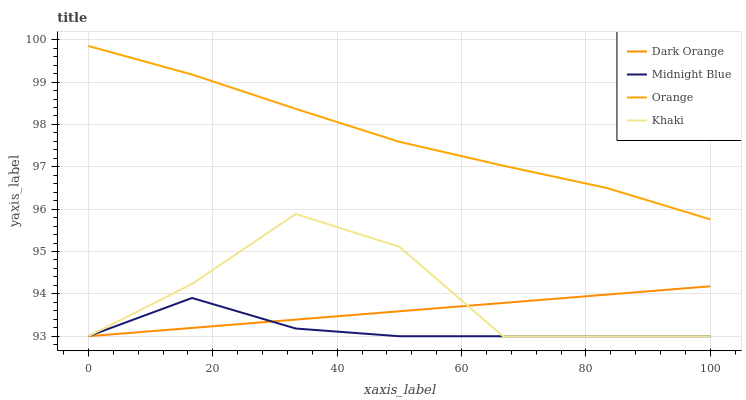Does Midnight Blue have the minimum area under the curve?
Answer yes or no. Yes. Does Orange have the maximum area under the curve?
Answer yes or no. Yes. Does Dark Orange have the minimum area under the curve?
Answer yes or no. No. Does Dark Orange have the maximum area under the curve?
Answer yes or no. No. Is Dark Orange the smoothest?
Answer yes or no. Yes. Is Khaki the roughest?
Answer yes or no. Yes. Is Khaki the smoothest?
Answer yes or no. No. Is Dark Orange the roughest?
Answer yes or no. No. Does Orange have the highest value?
Answer yes or no. Yes. Does Dark Orange have the highest value?
Answer yes or no. No. Is Khaki less than Orange?
Answer yes or no. Yes. Is Orange greater than Dark Orange?
Answer yes or no. Yes. Does Dark Orange intersect Khaki?
Answer yes or no. Yes. Is Dark Orange less than Khaki?
Answer yes or no. No. Is Dark Orange greater than Khaki?
Answer yes or no. No. Does Khaki intersect Orange?
Answer yes or no. No. 